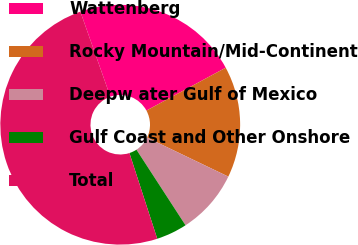Convert chart. <chart><loc_0><loc_0><loc_500><loc_500><pie_chart><fcel>Wattenberg<fcel>Rocky Mountain/Mid-Continent<fcel>Deepw ater Gulf of Mexico<fcel>Gulf Coast and Other Onshore<fcel>Total<nl><fcel>22.51%<fcel>15.01%<fcel>8.71%<fcel>4.17%<fcel>49.6%<nl></chart> 